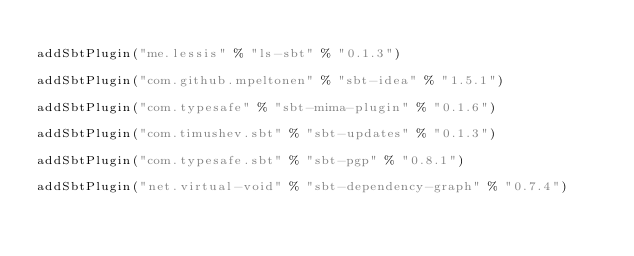Convert code to text. <code><loc_0><loc_0><loc_500><loc_500><_Scala_>
addSbtPlugin("me.lessis" % "ls-sbt" % "0.1.3")

addSbtPlugin("com.github.mpeltonen" % "sbt-idea" % "1.5.1")

addSbtPlugin("com.typesafe" % "sbt-mima-plugin" % "0.1.6")

addSbtPlugin("com.timushev.sbt" % "sbt-updates" % "0.1.3")

addSbtPlugin("com.typesafe.sbt" % "sbt-pgp" % "0.8.1")

addSbtPlugin("net.virtual-void" % "sbt-dependency-graph" % "0.7.4")</code> 